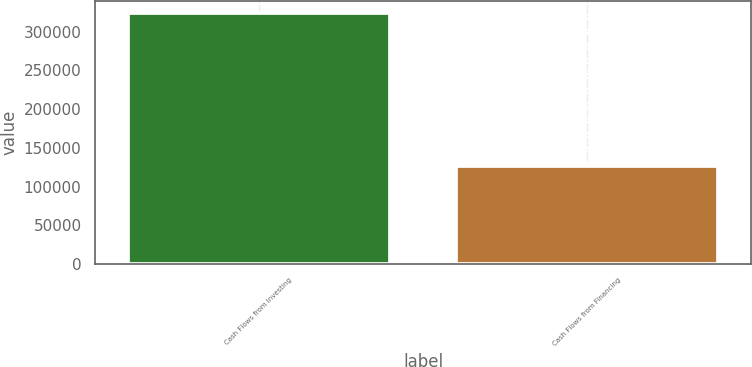<chart> <loc_0><loc_0><loc_500><loc_500><bar_chart><fcel>Cash Flows from Investing<fcel>Cash Flows from Financing<nl><fcel>323902<fcel>126873<nl></chart> 